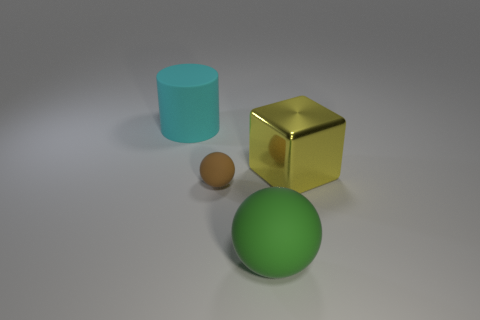Add 1 tiny green cylinders. How many objects exist? 5 Subtract all blocks. How many objects are left? 3 Add 4 matte cylinders. How many matte cylinders are left? 5 Add 4 large yellow shiny things. How many large yellow shiny things exist? 5 Subtract 0 gray cylinders. How many objects are left? 4 Subtract all blue cylinders. Subtract all big spheres. How many objects are left? 3 